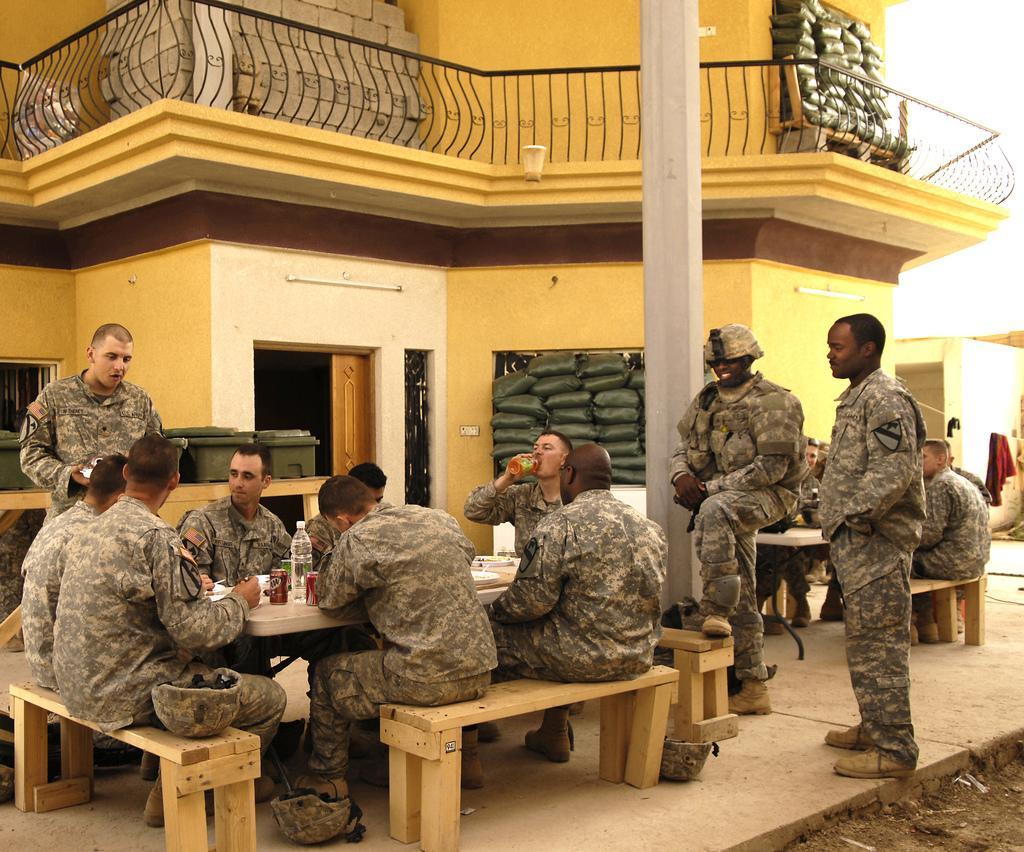Could you give a brief overview of what you see in this image? In the given image we can see that, the army people are sitting and some of them are standing. These are the water bottles, beside them there is a building and a pole. 